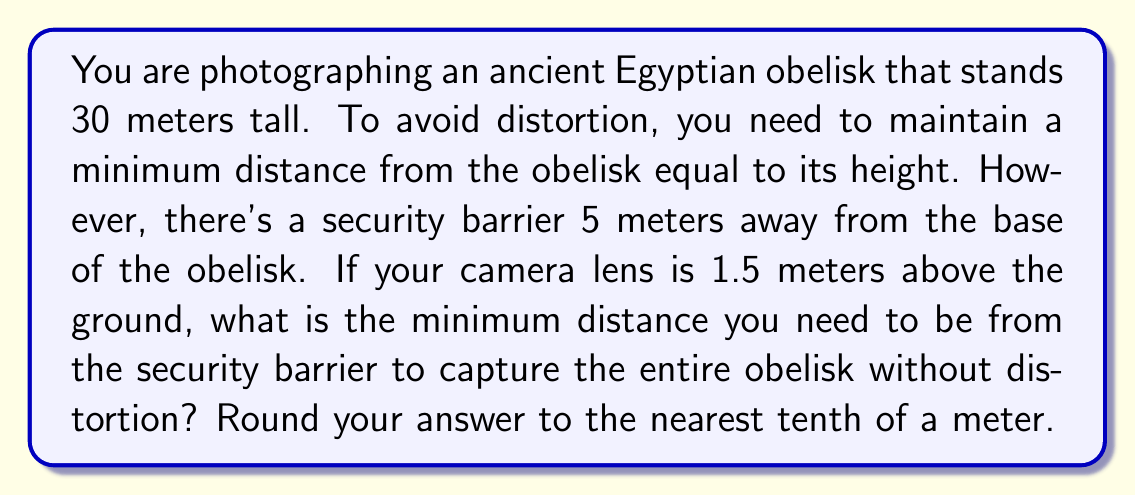Help me with this question. Let's approach this step-by-step:

1) First, let's visualize the problem:

[asy]
import geometry;

size(200);

pair A = (0,0), B = (0,30), C = (35,0), D = (35,1.5);
draw(A--B--C--D--A);
draw((5,0)--(5,30), dashed);

label("Obelisk", (0,15), W);
label("Camera", (35,1.5), E);
label("Security barrier", (5,15), E);

dot("A", A, SW);
dot("B", B, NW);
dot("C", C, SE);
dot("D", D, NE);

label("30m", (0,15), W);
label("5m", (2.5,0), S);
label("x", (20,0), S);
label("1.5m", (35,0.75), E);
[/asy]

2) Let's define our variables:
   - Let $x$ be the distance from the security barrier to the camera.

3) We know that for no distortion, the total distance from the obelisk to the camera must be at least equal to the height of the obelisk. So:

   $5 + x \geq 30$

4) However, we need to consider the height of the camera lens. We can use similar triangles to set up our equation:

   $\frac{30}{5+x} = \frac{31.5}{x}$

5) Cross multiply:

   $30x = (5+x)(31.5)$
   $30x = 157.5 + 31.5x$

6) Solve for $x$:

   $30x - 31.5x = 157.5$
   $-1.5x = 157.5$
   $x = 105$

7) Therefore, the minimum distance from the security barrier to the camera is 105 meters.

8) The total distance from the obelisk to the camera is $5 + 105 = 110$ meters.

9) Rounding to the nearest tenth of a meter: 105.0 meters.
Answer: 105.0 meters 